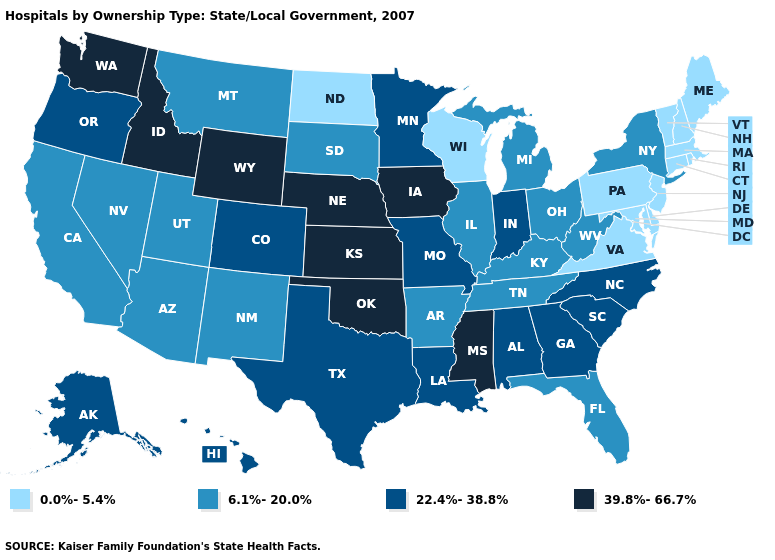Does the first symbol in the legend represent the smallest category?
Keep it brief. Yes. Name the states that have a value in the range 22.4%-38.8%?
Keep it brief. Alabama, Alaska, Colorado, Georgia, Hawaii, Indiana, Louisiana, Minnesota, Missouri, North Carolina, Oregon, South Carolina, Texas. Does Texas have a higher value than Minnesota?
Keep it brief. No. What is the highest value in the USA?
Be succinct. 39.8%-66.7%. Does Georgia have a lower value than Oklahoma?
Keep it brief. Yes. Which states have the highest value in the USA?
Write a very short answer. Idaho, Iowa, Kansas, Mississippi, Nebraska, Oklahoma, Washington, Wyoming. What is the value of Utah?
Write a very short answer. 6.1%-20.0%. Name the states that have a value in the range 22.4%-38.8%?
Answer briefly. Alabama, Alaska, Colorado, Georgia, Hawaii, Indiana, Louisiana, Minnesota, Missouri, North Carolina, Oregon, South Carolina, Texas. What is the lowest value in the USA?
Quick response, please. 0.0%-5.4%. Among the states that border North Carolina , does Virginia have the lowest value?
Quick response, please. Yes. Does South Dakota have a lower value than Illinois?
Quick response, please. No. Does Louisiana have the same value as Utah?
Concise answer only. No. Among the states that border Arizona , which have the lowest value?
Give a very brief answer. California, Nevada, New Mexico, Utah. What is the lowest value in the Northeast?
Concise answer only. 0.0%-5.4%. Name the states that have a value in the range 6.1%-20.0%?
Write a very short answer. Arizona, Arkansas, California, Florida, Illinois, Kentucky, Michigan, Montana, Nevada, New Mexico, New York, Ohio, South Dakota, Tennessee, Utah, West Virginia. 